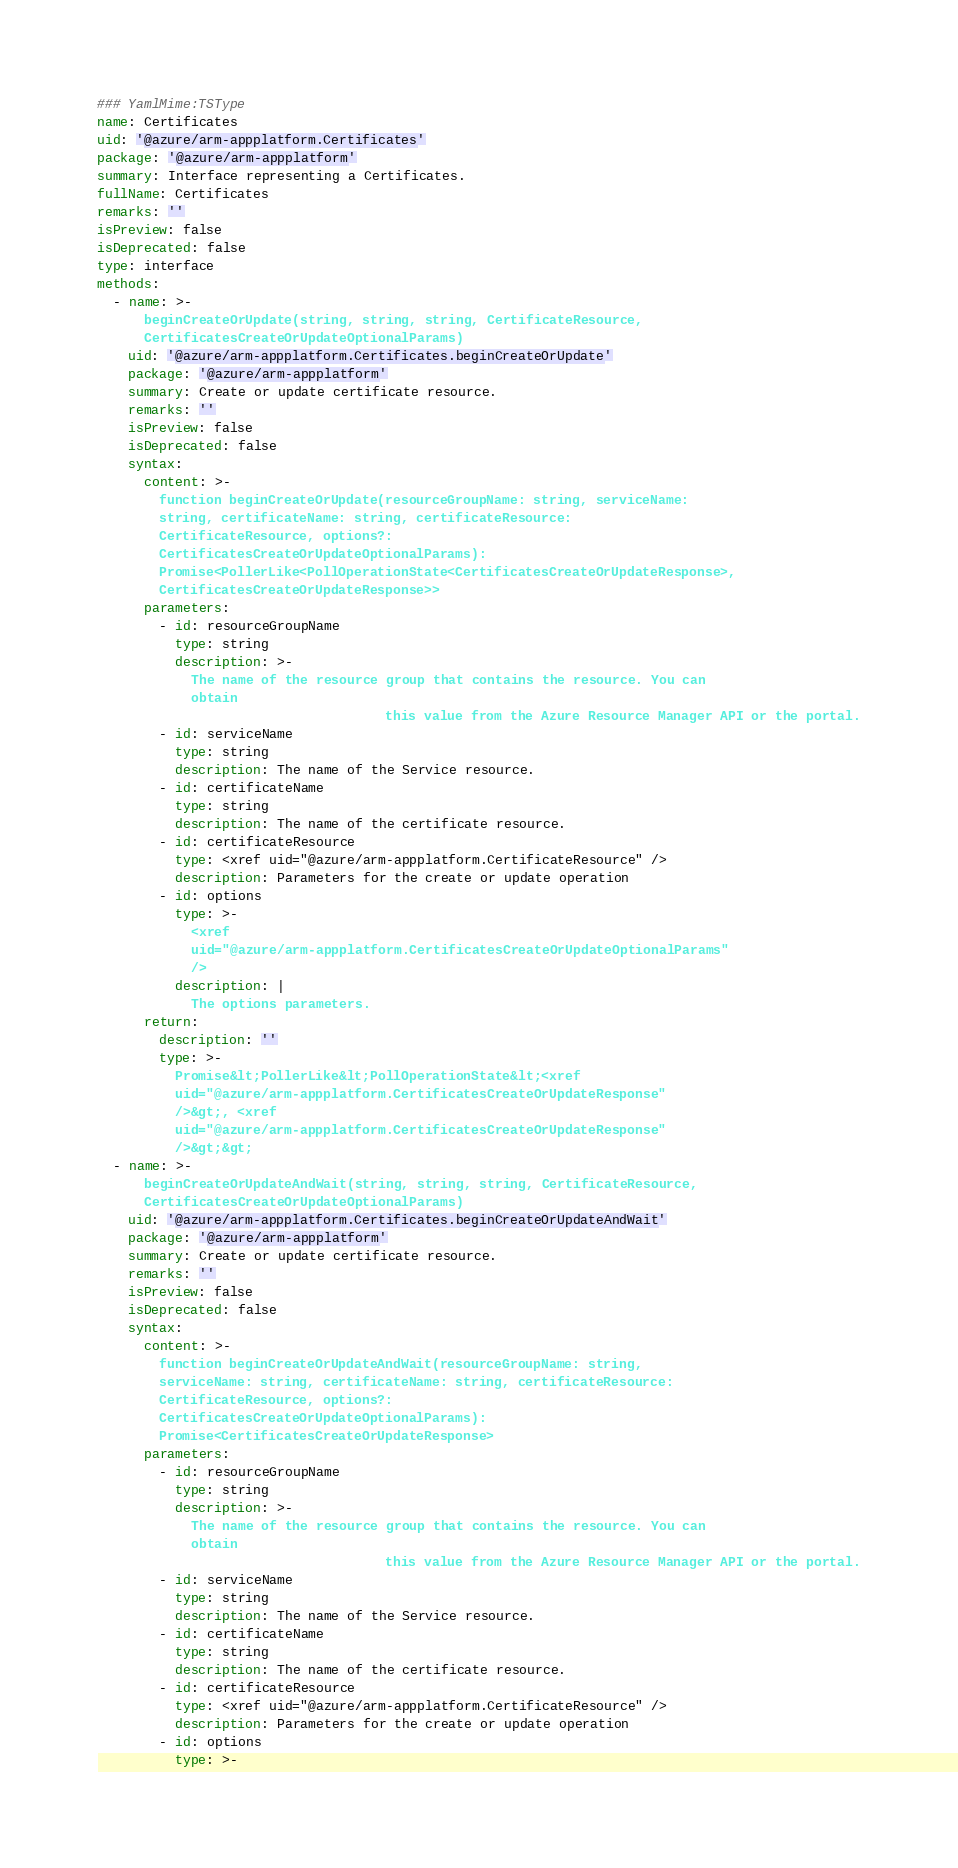<code> <loc_0><loc_0><loc_500><loc_500><_YAML_>### YamlMime:TSType
name: Certificates
uid: '@azure/arm-appplatform.Certificates'
package: '@azure/arm-appplatform'
summary: Interface representing a Certificates.
fullName: Certificates
remarks: ''
isPreview: false
isDeprecated: false
type: interface
methods:
  - name: >-
      beginCreateOrUpdate(string, string, string, CertificateResource,
      CertificatesCreateOrUpdateOptionalParams)
    uid: '@azure/arm-appplatform.Certificates.beginCreateOrUpdate'
    package: '@azure/arm-appplatform'
    summary: Create or update certificate resource.
    remarks: ''
    isPreview: false
    isDeprecated: false
    syntax:
      content: >-
        function beginCreateOrUpdate(resourceGroupName: string, serviceName:
        string, certificateName: string, certificateResource:
        CertificateResource, options?:
        CertificatesCreateOrUpdateOptionalParams):
        Promise<PollerLike<PollOperationState<CertificatesCreateOrUpdateResponse>,
        CertificatesCreateOrUpdateResponse>>
      parameters:
        - id: resourceGroupName
          type: string
          description: >-
            The name of the resource group that contains the resource. You can
            obtain
                                     this value from the Azure Resource Manager API or the portal.
        - id: serviceName
          type: string
          description: The name of the Service resource.
        - id: certificateName
          type: string
          description: The name of the certificate resource.
        - id: certificateResource
          type: <xref uid="@azure/arm-appplatform.CertificateResource" />
          description: Parameters for the create or update operation
        - id: options
          type: >-
            <xref
            uid="@azure/arm-appplatform.CertificatesCreateOrUpdateOptionalParams"
            />
          description: |
            The options parameters.
      return:
        description: ''
        type: >-
          Promise&lt;PollerLike&lt;PollOperationState&lt;<xref
          uid="@azure/arm-appplatform.CertificatesCreateOrUpdateResponse"
          />&gt;, <xref
          uid="@azure/arm-appplatform.CertificatesCreateOrUpdateResponse"
          />&gt;&gt;
  - name: >-
      beginCreateOrUpdateAndWait(string, string, string, CertificateResource,
      CertificatesCreateOrUpdateOptionalParams)
    uid: '@azure/arm-appplatform.Certificates.beginCreateOrUpdateAndWait'
    package: '@azure/arm-appplatform'
    summary: Create or update certificate resource.
    remarks: ''
    isPreview: false
    isDeprecated: false
    syntax:
      content: >-
        function beginCreateOrUpdateAndWait(resourceGroupName: string,
        serviceName: string, certificateName: string, certificateResource:
        CertificateResource, options?:
        CertificatesCreateOrUpdateOptionalParams):
        Promise<CertificatesCreateOrUpdateResponse>
      parameters:
        - id: resourceGroupName
          type: string
          description: >-
            The name of the resource group that contains the resource. You can
            obtain
                                     this value from the Azure Resource Manager API or the portal.
        - id: serviceName
          type: string
          description: The name of the Service resource.
        - id: certificateName
          type: string
          description: The name of the certificate resource.
        - id: certificateResource
          type: <xref uid="@azure/arm-appplatform.CertificateResource" />
          description: Parameters for the create or update operation
        - id: options
          type: >-</code> 